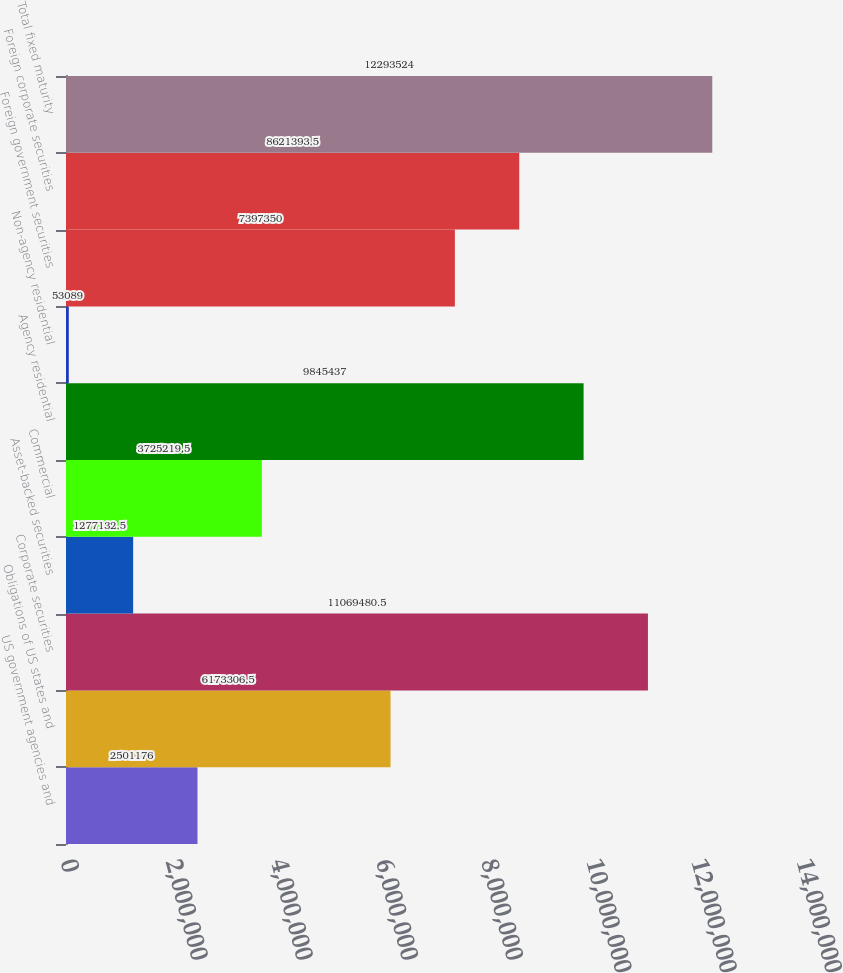Convert chart to OTSL. <chart><loc_0><loc_0><loc_500><loc_500><bar_chart><fcel>US government agencies and<fcel>Obligations of US states and<fcel>Corporate securities<fcel>Asset-backed securities<fcel>Commercial<fcel>Agency residential<fcel>Non-agency residential<fcel>Foreign government securities<fcel>Foreign corporate securities<fcel>Total fixed maturity<nl><fcel>2.50118e+06<fcel>6.17331e+06<fcel>1.10695e+07<fcel>1.27713e+06<fcel>3.72522e+06<fcel>9.84544e+06<fcel>53089<fcel>7.39735e+06<fcel>8.62139e+06<fcel>1.22935e+07<nl></chart> 